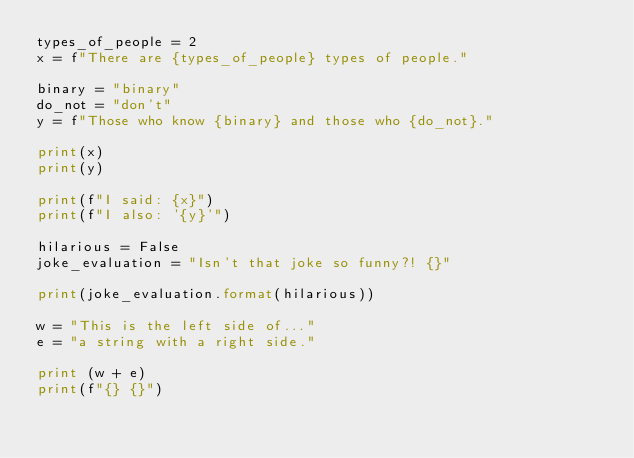<code> <loc_0><loc_0><loc_500><loc_500><_Python_>types_of_people = 2
x = f"There are {types_of_people} types of people."

binary = "binary"
do_not = "don't"
y = f"Those who know {binary} and those who {do_not}."

print(x)
print(y)

print(f"I said: {x}")
print(f"I also: '{y}'")

hilarious = False
joke_evaluation = "Isn't that joke so funny?! {}"

print(joke_evaluation.format(hilarious))

w = "This is the left side of..."
e = "a string with a right side."

print (w + e)
print(f"{} {}")
</code> 